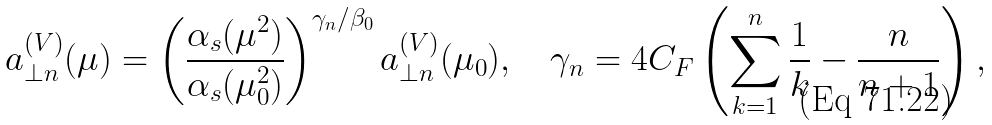<formula> <loc_0><loc_0><loc_500><loc_500>a _ { \perp n } ^ { ( V ) } ( \mu ) = \left ( \frac { \alpha _ { s } ( \mu ^ { 2 } ) } { \alpha _ { s } ( \mu _ { 0 } ^ { 2 } ) } \right ) ^ { \gamma _ { n } / \beta _ { 0 } } a _ { \perp n } ^ { ( V ) } ( \mu _ { 0 } ) , \quad \gamma _ { n } = 4 C _ { F } \left ( \sum _ { k = 1 } ^ { n } \frac { 1 } { k } - \frac { n } { n + 1 } \right ) ,</formula> 